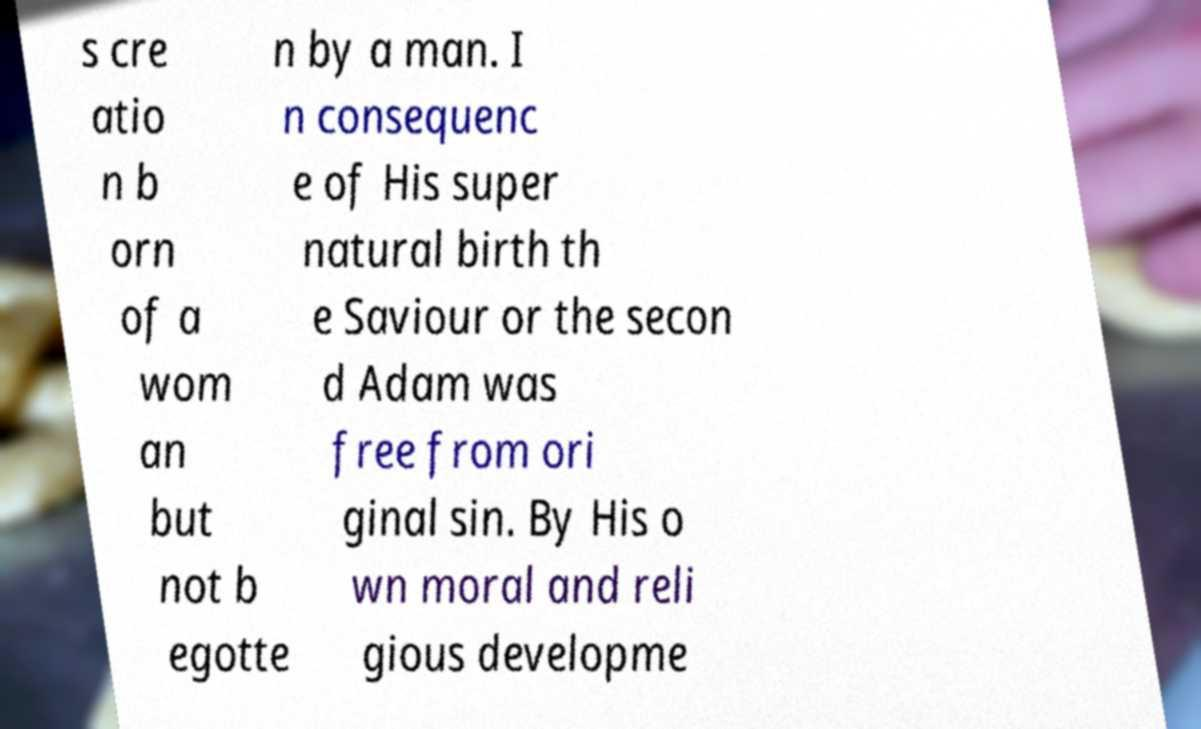For documentation purposes, I need the text within this image transcribed. Could you provide that? s cre atio n b orn of a wom an but not b egotte n by a man. I n consequenc e of His super natural birth th e Saviour or the secon d Adam was free from ori ginal sin. By His o wn moral and reli gious developme 